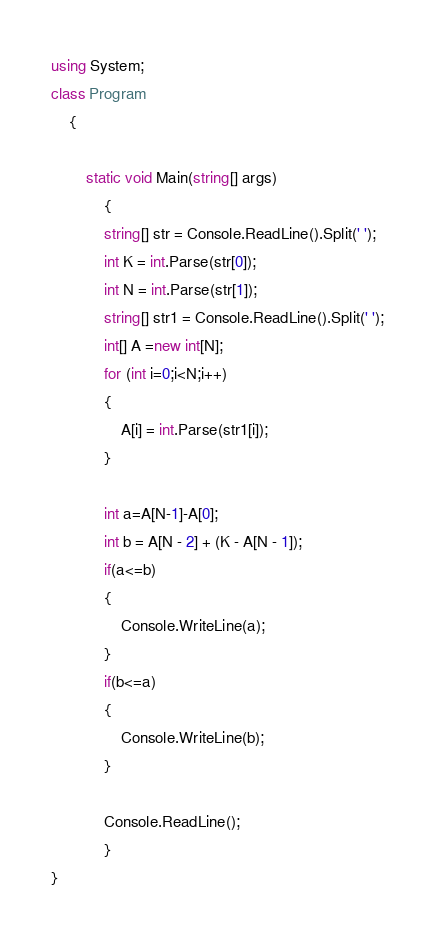<code> <loc_0><loc_0><loc_500><loc_500><_C#_>using System;
class Program
    {
     
        static void Main(string[] args)
            {
            string[] str = Console.ReadLine().Split(' ');
            int K = int.Parse(str[0]);
            int N = int.Parse(str[1]);
            string[] str1 = Console.ReadLine().Split(' ');
            int[] A =new int[N];
            for (int i=0;i<N;i++)
            {
                A[i] = int.Parse(str1[i]);
            }

            int a=A[N-1]-A[0];
            int b = A[N - 2] + (K - A[N - 1]);
            if(a<=b)
            {
                Console.WriteLine(a);
            }
            if(b<=a)
            {
                Console.WriteLine(b);
            }
           
            Console.ReadLine();
            }
}</code> 